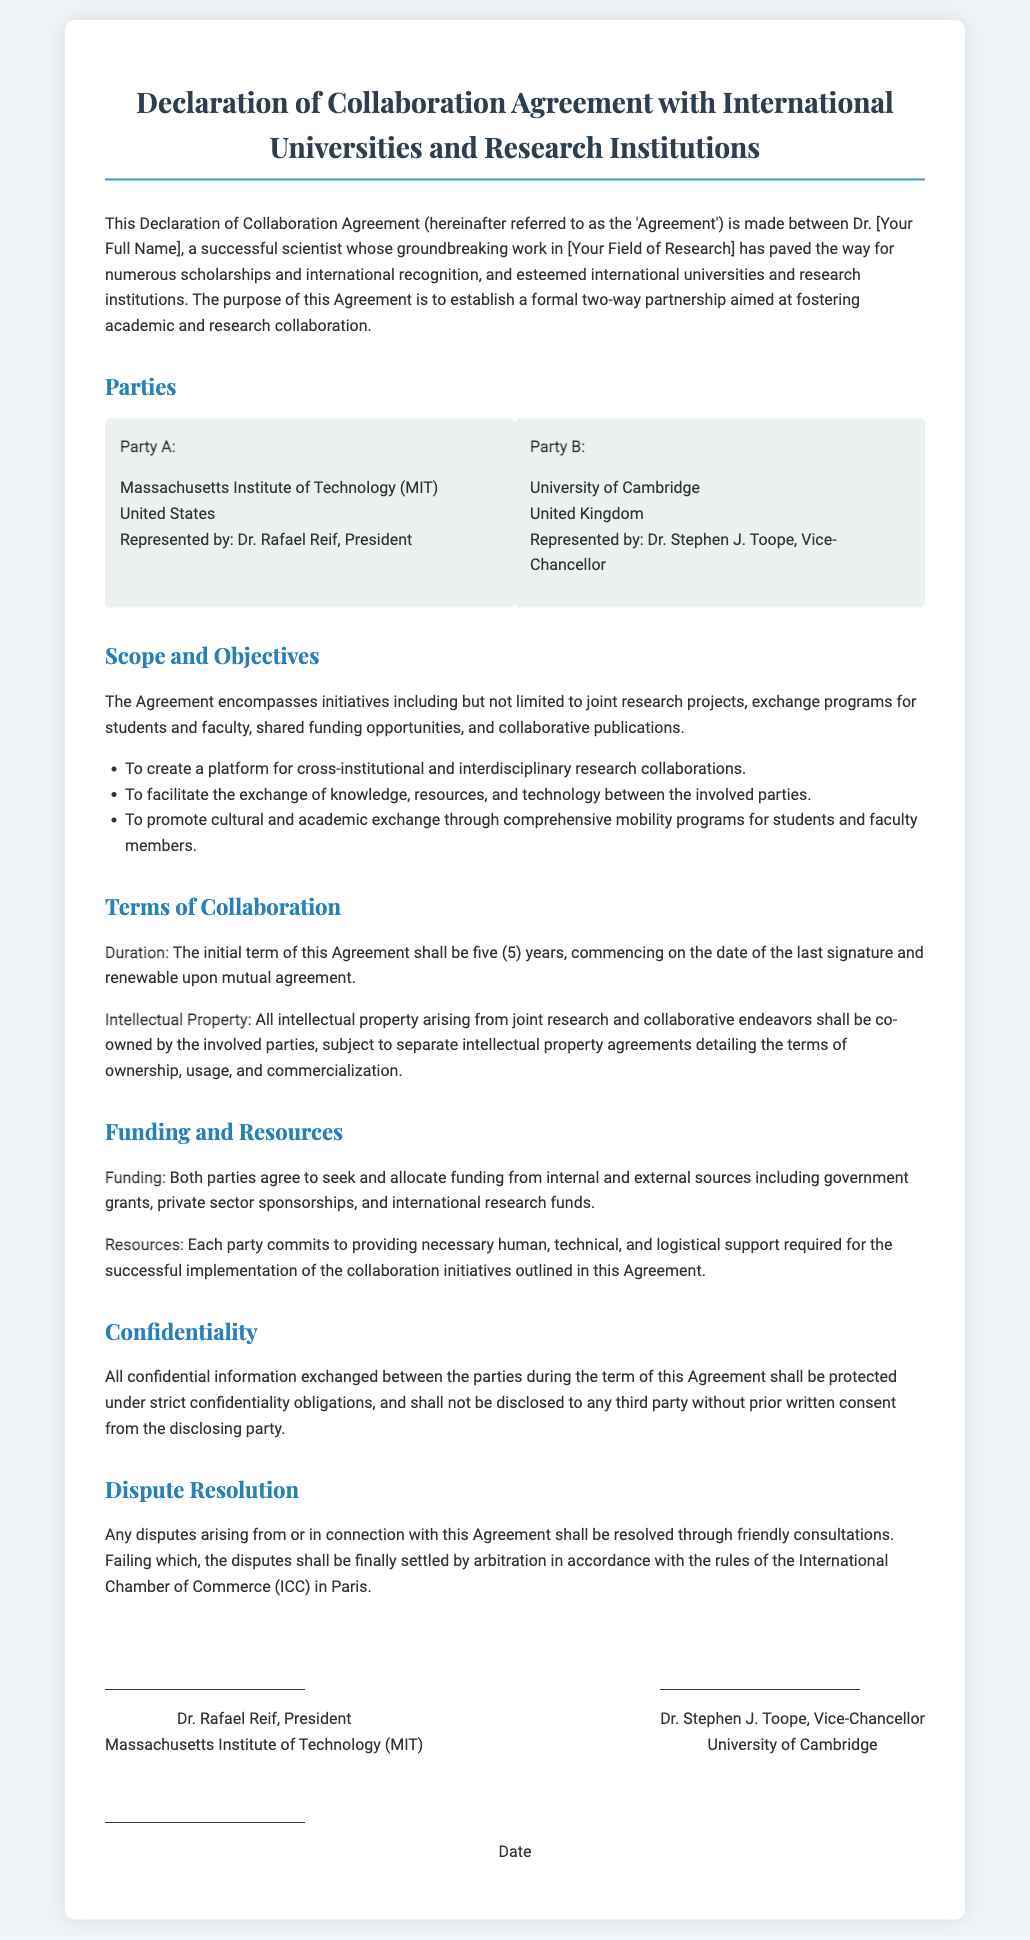What is the title of the document? The title of the document is prominently displayed at the top and describes its purpose.
Answer: Declaration of Collaboration Agreement with International Universities and Research Institutions Who represents the Massachusetts Institute of Technology? The document states the representative for MIT in the section about the parties involved in the agreement.
Answer: Dr. Rafael Reif What is the duration of the agreement? The duration is mentioned clearly under the terms of collaboration, specifying how long the agreement will last.
Answer: five (5) years What is the main purpose of this agreement? The purpose is outlined in the opening paragraph of the document, emphasizing the focus of the collaboration.
Answer: fostering academic and research collaboration Which two institutions are involved in this agreement? The parties section lists the institutions involved in the collaboration agreement.
Answer: Massachusetts Institute of Technology (MIT) and University of Cambridge What type of research initiatives are included in the agreement? The scope and objectives section lists various initiatives to be undertaken as part of the collaboration.
Answer: joint research projects Who is the Vice-Chancellor of the University of Cambridge? The document provides the name of the representative for the University of Cambridge when mentioning the parties.
Answer: Dr. Stephen J. Toope Where will disputes be settled if they arise? The document specifies the location for arbitration in case of disputes in the dispute resolution section.
Answer: Paris What is the confidentiality obligation mentioned in the agreement? The confidentiality section outlines the responsibilities regarding the sharing of confidential information.
Answer: strict confidentiality obligations 